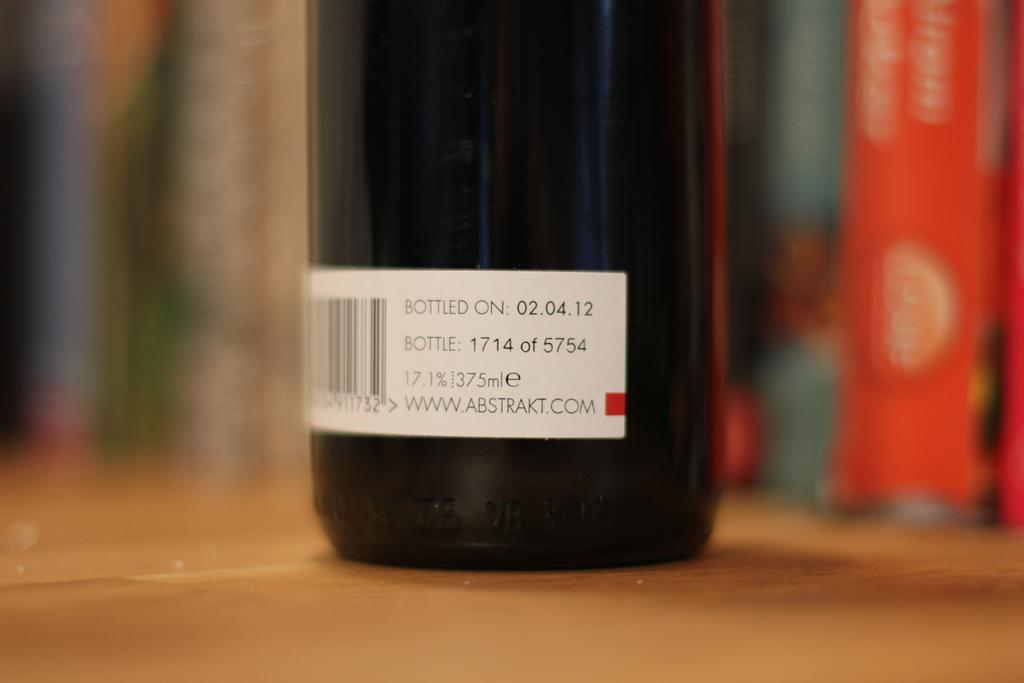<image>
Offer a succinct explanation of the picture presented. A dark bottle with a label showing their website to be WWW.ABSTRAKT.COM. 